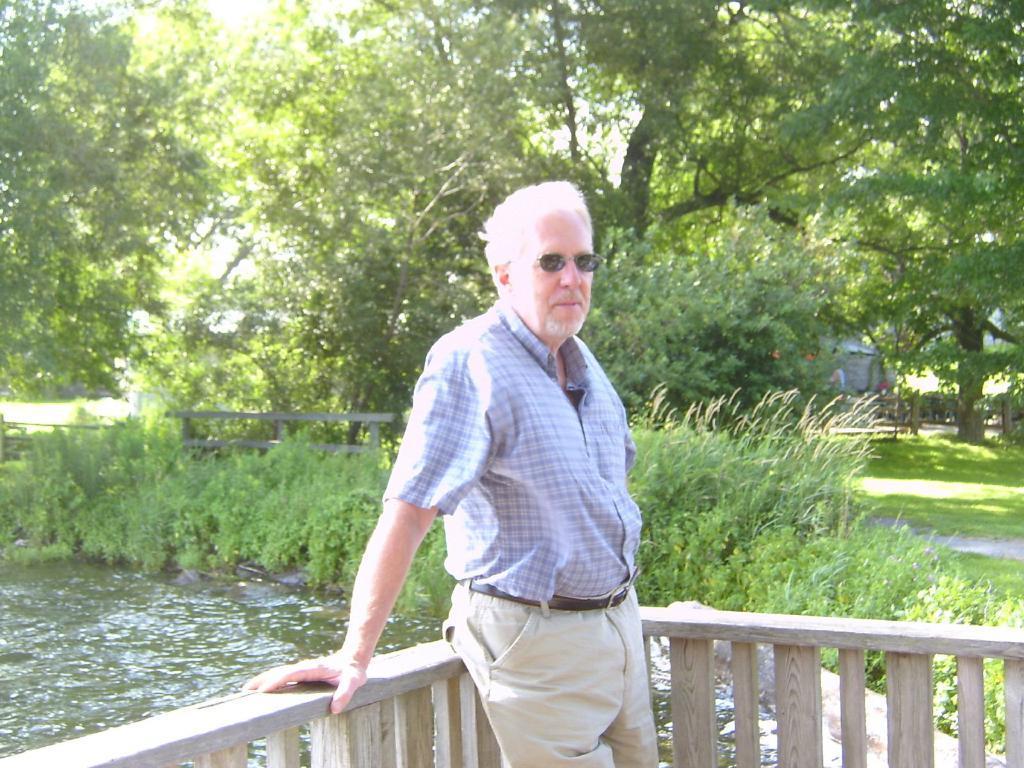Could you give a brief overview of what you see in this image? In the picture there is a man standing near a wooden fence, behind the man there is water, there are plants and there are trees present. 